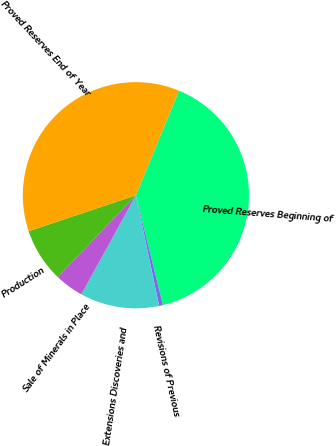Convert chart to OTSL. <chart><loc_0><loc_0><loc_500><loc_500><pie_chart><fcel>Proved Reserves Beginning of<fcel>Revisions of Previous<fcel>Extensions Discoveries and<fcel>Sale of Minerals in Place<fcel>Production<fcel>Proved Reserves End of Year<nl><fcel>39.95%<fcel>0.54%<fcel>11.3%<fcel>4.13%<fcel>7.72%<fcel>36.36%<nl></chart> 